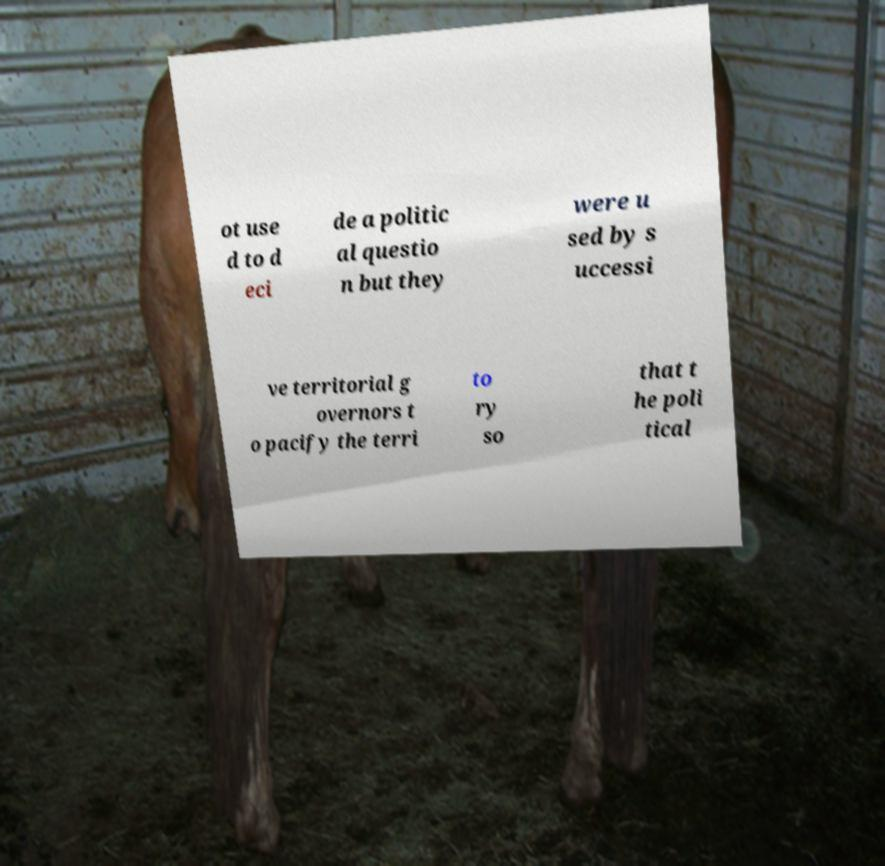Please identify and transcribe the text found in this image. ot use d to d eci de a politic al questio n but they were u sed by s uccessi ve territorial g overnors t o pacify the terri to ry so that t he poli tical 